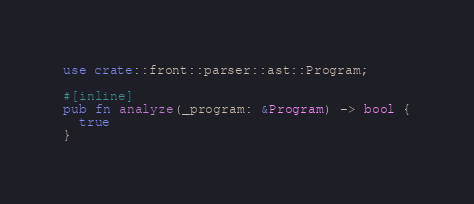<code> <loc_0><loc_0><loc_500><loc_500><_Rust_>use crate::front::parser::ast::Program;

#[inline]
pub fn analyze(_program: &Program) -> bool {
  true
}
</code> 